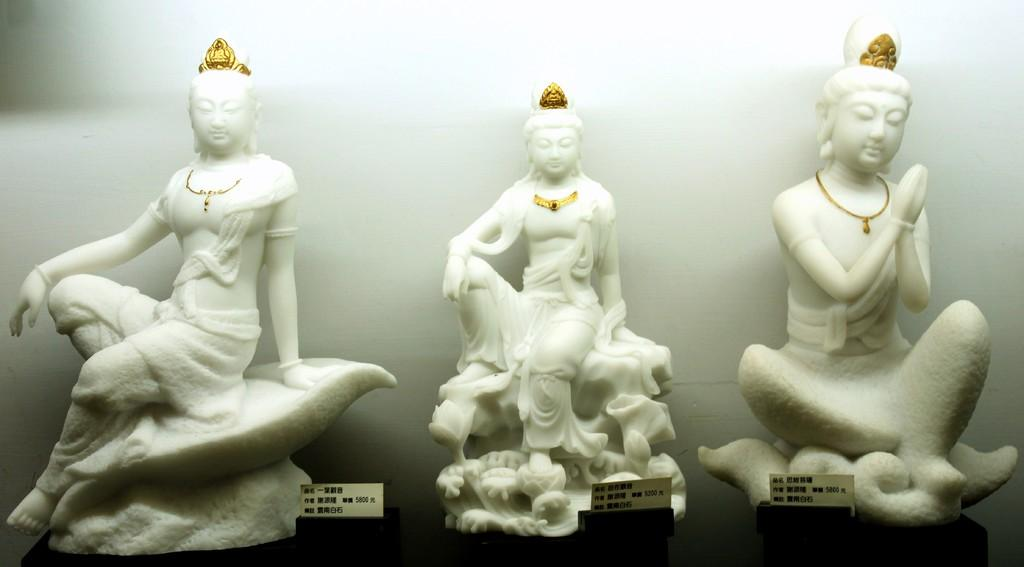What can be seen in the image? There are idols in the image. What is behind the idols? There is a wall behind the idols. What type of pain is mom experiencing in the image? There is no mention of a mom or any pain in the image; it only features idols and a wall. 